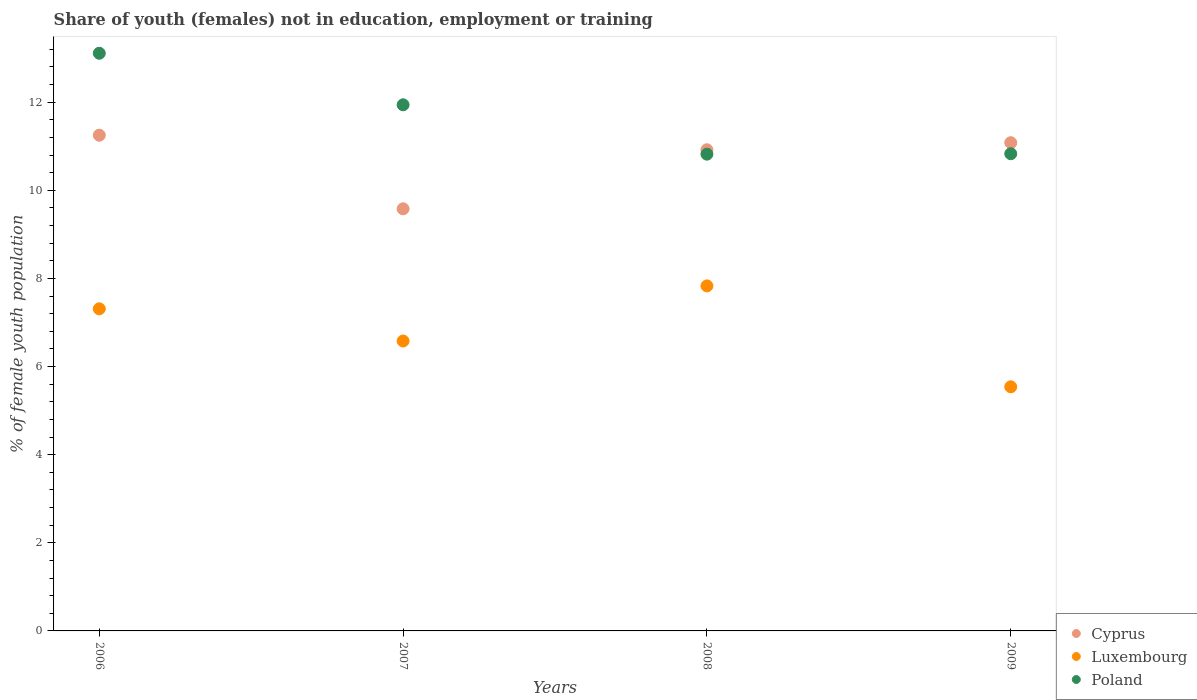Is the number of dotlines equal to the number of legend labels?
Make the answer very short. Yes. What is the percentage of unemployed female population in in Luxembourg in 2006?
Offer a very short reply. 7.31. Across all years, what is the maximum percentage of unemployed female population in in Luxembourg?
Your answer should be compact. 7.83. Across all years, what is the minimum percentage of unemployed female population in in Poland?
Make the answer very short. 10.82. In which year was the percentage of unemployed female population in in Cyprus maximum?
Give a very brief answer. 2006. What is the total percentage of unemployed female population in in Poland in the graph?
Offer a terse response. 46.7. What is the difference between the percentage of unemployed female population in in Poland in 2007 and that in 2009?
Ensure brevity in your answer.  1.11. What is the difference between the percentage of unemployed female population in in Poland in 2006 and the percentage of unemployed female population in in Luxembourg in 2009?
Offer a very short reply. 7.57. What is the average percentage of unemployed female population in in Poland per year?
Your response must be concise. 11.67. In the year 2009, what is the difference between the percentage of unemployed female population in in Cyprus and percentage of unemployed female population in in Luxembourg?
Make the answer very short. 5.54. What is the ratio of the percentage of unemployed female population in in Poland in 2007 to that in 2009?
Your answer should be very brief. 1.1. Is the percentage of unemployed female population in in Luxembourg in 2006 less than that in 2007?
Ensure brevity in your answer.  No. Is the difference between the percentage of unemployed female population in in Cyprus in 2007 and 2008 greater than the difference between the percentage of unemployed female population in in Luxembourg in 2007 and 2008?
Provide a succinct answer. No. What is the difference between the highest and the second highest percentage of unemployed female population in in Poland?
Give a very brief answer. 1.17. What is the difference between the highest and the lowest percentage of unemployed female population in in Cyprus?
Your response must be concise. 1.67. Does the percentage of unemployed female population in in Luxembourg monotonically increase over the years?
Offer a very short reply. No. How many dotlines are there?
Your answer should be very brief. 3. How many years are there in the graph?
Ensure brevity in your answer.  4. What is the difference between two consecutive major ticks on the Y-axis?
Provide a short and direct response. 2. Are the values on the major ticks of Y-axis written in scientific E-notation?
Your response must be concise. No. Does the graph contain any zero values?
Ensure brevity in your answer.  No. Does the graph contain grids?
Offer a terse response. No. Where does the legend appear in the graph?
Provide a succinct answer. Bottom right. How many legend labels are there?
Keep it short and to the point. 3. How are the legend labels stacked?
Your answer should be very brief. Vertical. What is the title of the graph?
Your answer should be compact. Share of youth (females) not in education, employment or training. What is the label or title of the X-axis?
Your response must be concise. Years. What is the label or title of the Y-axis?
Make the answer very short. % of female youth population. What is the % of female youth population in Cyprus in 2006?
Make the answer very short. 11.25. What is the % of female youth population in Luxembourg in 2006?
Your answer should be very brief. 7.31. What is the % of female youth population of Poland in 2006?
Your answer should be compact. 13.11. What is the % of female youth population of Cyprus in 2007?
Your answer should be compact. 9.58. What is the % of female youth population of Luxembourg in 2007?
Your response must be concise. 6.58. What is the % of female youth population in Poland in 2007?
Make the answer very short. 11.94. What is the % of female youth population in Cyprus in 2008?
Offer a terse response. 10.92. What is the % of female youth population in Luxembourg in 2008?
Give a very brief answer. 7.83. What is the % of female youth population in Poland in 2008?
Give a very brief answer. 10.82. What is the % of female youth population of Cyprus in 2009?
Your response must be concise. 11.08. What is the % of female youth population in Luxembourg in 2009?
Provide a short and direct response. 5.54. What is the % of female youth population in Poland in 2009?
Your response must be concise. 10.83. Across all years, what is the maximum % of female youth population of Cyprus?
Make the answer very short. 11.25. Across all years, what is the maximum % of female youth population of Luxembourg?
Your answer should be compact. 7.83. Across all years, what is the maximum % of female youth population in Poland?
Ensure brevity in your answer.  13.11. Across all years, what is the minimum % of female youth population in Cyprus?
Your answer should be very brief. 9.58. Across all years, what is the minimum % of female youth population in Luxembourg?
Give a very brief answer. 5.54. Across all years, what is the minimum % of female youth population of Poland?
Offer a very short reply. 10.82. What is the total % of female youth population in Cyprus in the graph?
Offer a terse response. 42.83. What is the total % of female youth population in Luxembourg in the graph?
Provide a short and direct response. 27.26. What is the total % of female youth population of Poland in the graph?
Your answer should be very brief. 46.7. What is the difference between the % of female youth population in Cyprus in 2006 and that in 2007?
Offer a very short reply. 1.67. What is the difference between the % of female youth population in Luxembourg in 2006 and that in 2007?
Your response must be concise. 0.73. What is the difference between the % of female youth population in Poland in 2006 and that in 2007?
Provide a short and direct response. 1.17. What is the difference between the % of female youth population in Cyprus in 2006 and that in 2008?
Provide a short and direct response. 0.33. What is the difference between the % of female youth population in Luxembourg in 2006 and that in 2008?
Provide a short and direct response. -0.52. What is the difference between the % of female youth population of Poland in 2006 and that in 2008?
Your answer should be very brief. 2.29. What is the difference between the % of female youth population in Cyprus in 2006 and that in 2009?
Your response must be concise. 0.17. What is the difference between the % of female youth population of Luxembourg in 2006 and that in 2009?
Make the answer very short. 1.77. What is the difference between the % of female youth population in Poland in 2006 and that in 2009?
Ensure brevity in your answer.  2.28. What is the difference between the % of female youth population in Cyprus in 2007 and that in 2008?
Ensure brevity in your answer.  -1.34. What is the difference between the % of female youth population of Luxembourg in 2007 and that in 2008?
Keep it short and to the point. -1.25. What is the difference between the % of female youth population in Poland in 2007 and that in 2008?
Provide a short and direct response. 1.12. What is the difference between the % of female youth population in Luxembourg in 2007 and that in 2009?
Offer a terse response. 1.04. What is the difference between the % of female youth population of Poland in 2007 and that in 2009?
Make the answer very short. 1.11. What is the difference between the % of female youth population in Cyprus in 2008 and that in 2009?
Offer a very short reply. -0.16. What is the difference between the % of female youth population of Luxembourg in 2008 and that in 2009?
Offer a terse response. 2.29. What is the difference between the % of female youth population in Poland in 2008 and that in 2009?
Provide a succinct answer. -0.01. What is the difference between the % of female youth population in Cyprus in 2006 and the % of female youth population in Luxembourg in 2007?
Offer a very short reply. 4.67. What is the difference between the % of female youth population in Cyprus in 2006 and the % of female youth population in Poland in 2007?
Make the answer very short. -0.69. What is the difference between the % of female youth population in Luxembourg in 2006 and the % of female youth population in Poland in 2007?
Ensure brevity in your answer.  -4.63. What is the difference between the % of female youth population in Cyprus in 2006 and the % of female youth population in Luxembourg in 2008?
Your answer should be very brief. 3.42. What is the difference between the % of female youth population in Cyprus in 2006 and the % of female youth population in Poland in 2008?
Provide a succinct answer. 0.43. What is the difference between the % of female youth population of Luxembourg in 2006 and the % of female youth population of Poland in 2008?
Provide a short and direct response. -3.51. What is the difference between the % of female youth population of Cyprus in 2006 and the % of female youth population of Luxembourg in 2009?
Make the answer very short. 5.71. What is the difference between the % of female youth population of Cyprus in 2006 and the % of female youth population of Poland in 2009?
Keep it short and to the point. 0.42. What is the difference between the % of female youth population in Luxembourg in 2006 and the % of female youth population in Poland in 2009?
Your answer should be compact. -3.52. What is the difference between the % of female youth population in Cyprus in 2007 and the % of female youth population in Poland in 2008?
Your answer should be compact. -1.24. What is the difference between the % of female youth population of Luxembourg in 2007 and the % of female youth population of Poland in 2008?
Your answer should be compact. -4.24. What is the difference between the % of female youth population in Cyprus in 2007 and the % of female youth population in Luxembourg in 2009?
Give a very brief answer. 4.04. What is the difference between the % of female youth population in Cyprus in 2007 and the % of female youth population in Poland in 2009?
Provide a succinct answer. -1.25. What is the difference between the % of female youth population of Luxembourg in 2007 and the % of female youth population of Poland in 2009?
Give a very brief answer. -4.25. What is the difference between the % of female youth population in Cyprus in 2008 and the % of female youth population in Luxembourg in 2009?
Provide a succinct answer. 5.38. What is the difference between the % of female youth population of Cyprus in 2008 and the % of female youth population of Poland in 2009?
Make the answer very short. 0.09. What is the difference between the % of female youth population of Luxembourg in 2008 and the % of female youth population of Poland in 2009?
Ensure brevity in your answer.  -3. What is the average % of female youth population of Cyprus per year?
Provide a short and direct response. 10.71. What is the average % of female youth population of Luxembourg per year?
Ensure brevity in your answer.  6.82. What is the average % of female youth population of Poland per year?
Ensure brevity in your answer.  11.68. In the year 2006, what is the difference between the % of female youth population in Cyprus and % of female youth population in Luxembourg?
Make the answer very short. 3.94. In the year 2006, what is the difference between the % of female youth population of Cyprus and % of female youth population of Poland?
Provide a succinct answer. -1.86. In the year 2007, what is the difference between the % of female youth population in Cyprus and % of female youth population in Luxembourg?
Provide a succinct answer. 3. In the year 2007, what is the difference between the % of female youth population in Cyprus and % of female youth population in Poland?
Offer a terse response. -2.36. In the year 2007, what is the difference between the % of female youth population in Luxembourg and % of female youth population in Poland?
Offer a terse response. -5.36. In the year 2008, what is the difference between the % of female youth population of Cyprus and % of female youth population of Luxembourg?
Your answer should be compact. 3.09. In the year 2008, what is the difference between the % of female youth population in Luxembourg and % of female youth population in Poland?
Your answer should be compact. -2.99. In the year 2009, what is the difference between the % of female youth population of Cyprus and % of female youth population of Luxembourg?
Offer a very short reply. 5.54. In the year 2009, what is the difference between the % of female youth population of Cyprus and % of female youth population of Poland?
Offer a very short reply. 0.25. In the year 2009, what is the difference between the % of female youth population of Luxembourg and % of female youth population of Poland?
Offer a terse response. -5.29. What is the ratio of the % of female youth population in Cyprus in 2006 to that in 2007?
Provide a short and direct response. 1.17. What is the ratio of the % of female youth population of Luxembourg in 2006 to that in 2007?
Offer a terse response. 1.11. What is the ratio of the % of female youth population of Poland in 2006 to that in 2007?
Ensure brevity in your answer.  1.1. What is the ratio of the % of female youth population in Cyprus in 2006 to that in 2008?
Keep it short and to the point. 1.03. What is the ratio of the % of female youth population of Luxembourg in 2006 to that in 2008?
Your answer should be very brief. 0.93. What is the ratio of the % of female youth population in Poland in 2006 to that in 2008?
Your response must be concise. 1.21. What is the ratio of the % of female youth population in Cyprus in 2006 to that in 2009?
Provide a succinct answer. 1.02. What is the ratio of the % of female youth population in Luxembourg in 2006 to that in 2009?
Your answer should be very brief. 1.32. What is the ratio of the % of female youth population of Poland in 2006 to that in 2009?
Your answer should be very brief. 1.21. What is the ratio of the % of female youth population of Cyprus in 2007 to that in 2008?
Provide a succinct answer. 0.88. What is the ratio of the % of female youth population in Luxembourg in 2007 to that in 2008?
Offer a terse response. 0.84. What is the ratio of the % of female youth population of Poland in 2007 to that in 2008?
Your response must be concise. 1.1. What is the ratio of the % of female youth population in Cyprus in 2007 to that in 2009?
Ensure brevity in your answer.  0.86. What is the ratio of the % of female youth population in Luxembourg in 2007 to that in 2009?
Make the answer very short. 1.19. What is the ratio of the % of female youth population in Poland in 2007 to that in 2009?
Provide a short and direct response. 1.1. What is the ratio of the % of female youth population of Cyprus in 2008 to that in 2009?
Provide a short and direct response. 0.99. What is the ratio of the % of female youth population in Luxembourg in 2008 to that in 2009?
Provide a succinct answer. 1.41. What is the difference between the highest and the second highest % of female youth population in Cyprus?
Give a very brief answer. 0.17. What is the difference between the highest and the second highest % of female youth population in Luxembourg?
Make the answer very short. 0.52. What is the difference between the highest and the second highest % of female youth population of Poland?
Make the answer very short. 1.17. What is the difference between the highest and the lowest % of female youth population in Cyprus?
Your answer should be compact. 1.67. What is the difference between the highest and the lowest % of female youth population of Luxembourg?
Your answer should be very brief. 2.29. What is the difference between the highest and the lowest % of female youth population of Poland?
Ensure brevity in your answer.  2.29. 